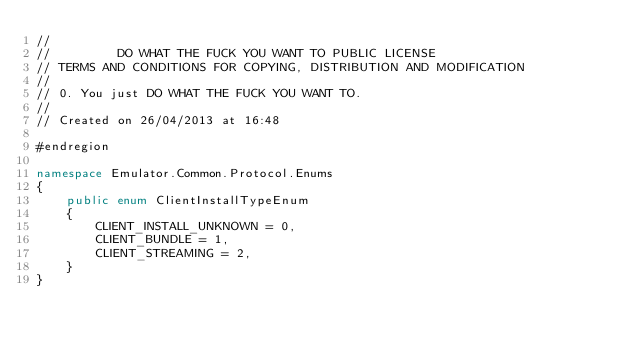<code> <loc_0><loc_0><loc_500><loc_500><_C#_>//  
//         DO WHAT THE FUCK YOU WANT TO PUBLIC LICENSE
// TERMS AND CONDITIONS FOR COPYING, DISTRIBUTION AND MODIFICATION
//  
// 0. You just DO WHAT THE FUCK YOU WANT TO.
// 
// Created on 26/04/2013 at 16:48

#endregion

namespace Emulator.Common.Protocol.Enums
{
    public enum ClientInstallTypeEnum
    {
        CLIENT_INSTALL_UNKNOWN = 0,
        CLIENT_BUNDLE = 1,
        CLIENT_STREAMING = 2,
    }
}</code> 